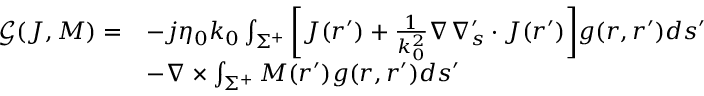<formula> <loc_0><loc_0><loc_500><loc_500>\begin{array} { r l } { \mathcal { G } ( J , M ) = } & { - j \eta _ { 0 } k _ { 0 } \int _ { \Sigma ^ { + } } { \left [ J ( r ^ { \prime } ) + \frac { 1 } { k _ { 0 } ^ { 2 } } \nabla \nabla _ { s } ^ { \prime } \cdot J ( r ^ { \prime } ) \right ] } g ( r , r ^ { \prime } ) d s ^ { \prime } } \\ & { - \nabla \times \int _ { \Sigma ^ { + } } { M } ( r ^ { \prime } ) g ( r , r ^ { \prime } ) d s ^ { \prime } } \end{array}</formula> 